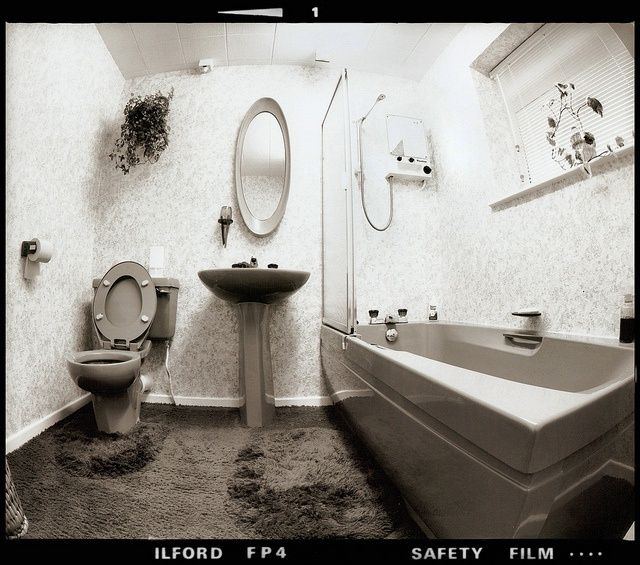Describe the objects in this image and their specific colors. I can see toilet in black, darkgray, gray, and lightgray tones, potted plant in black, gray, and darkgray tones, sink in black and gray tones, potted plant in black, lightgray, darkgray, and gray tones, and bottle in black, darkgray, lightgray, and gray tones in this image. 